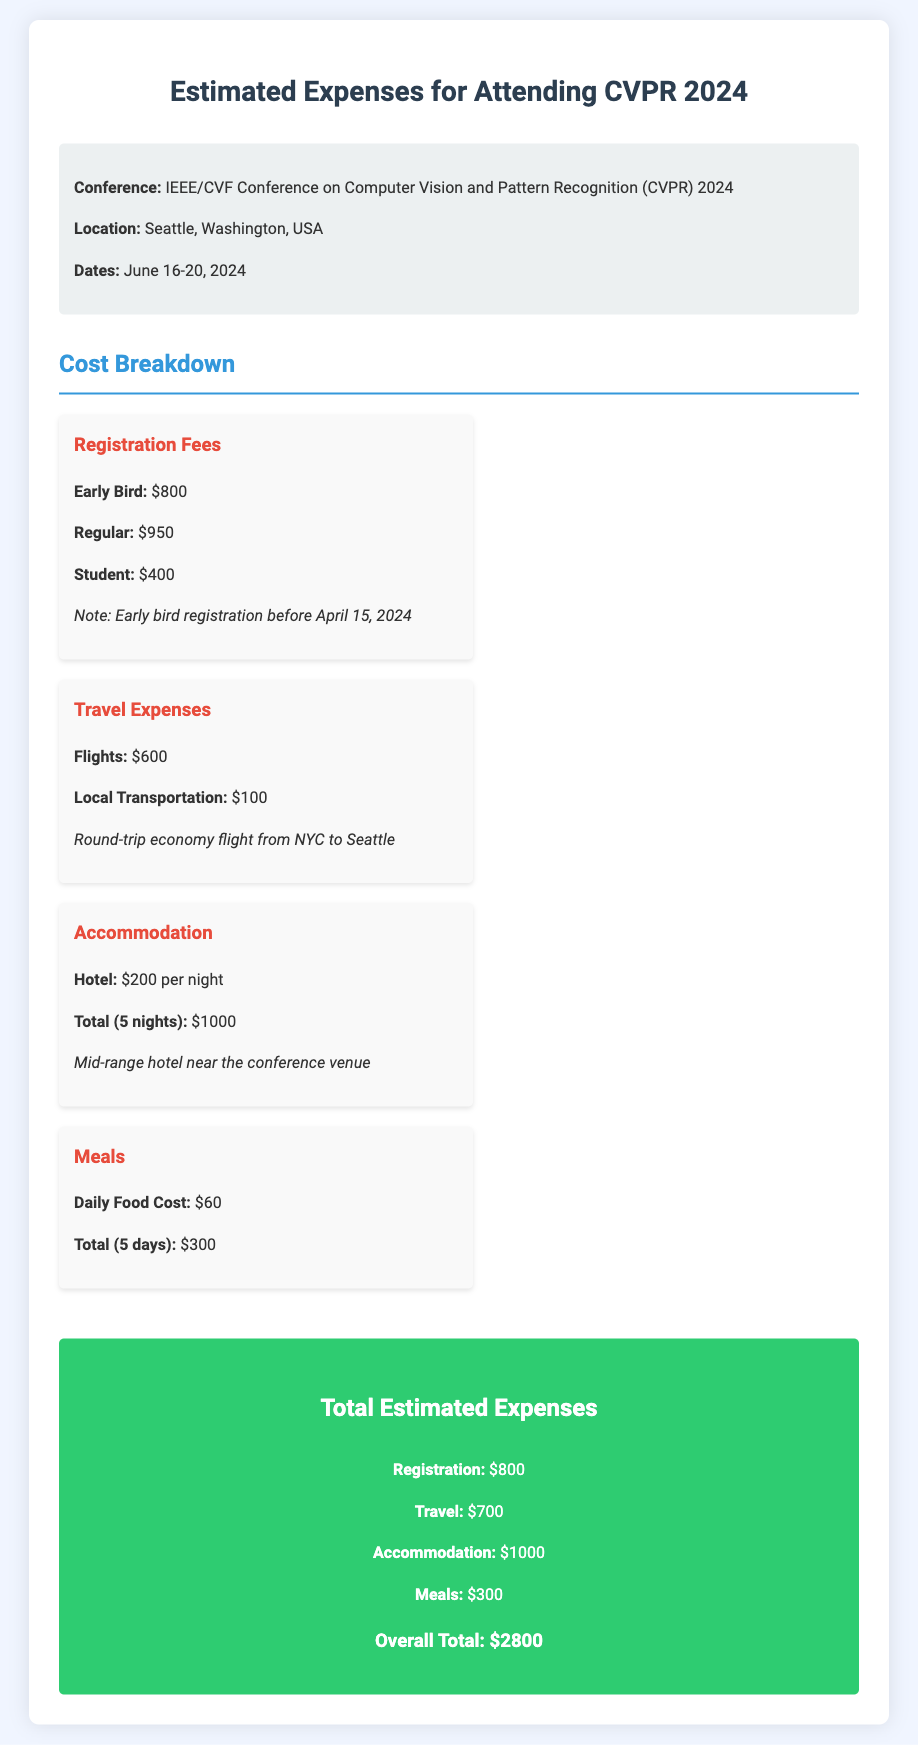What is the location of the conference? The location of the conference is specified in the document as Seattle, Washington, USA.
Answer: Seattle, Washington, USA What are the dates of CVPR 2024? The dates of the conference are given as June 16-20, 2024.
Answer: June 16-20, 2024 What is the early bird registration fee? The document states that the early bird registration fee is $800.
Answer: $800 How much is the hotel cost per night? The document mentions that the hotel costs $200 per night.
Answer: $200 What is the total estimated cost for meals? The total for meals is calculated for 5 days at $60 per day, totaling $300.
Answer: $300 How much is the total estimated expense for attending the conference? The overall total is the sum of registration, travel, accommodation, and meals, which is $2800.
Answer: $2800 If registered before April 15, 2024, what is the registration fee for students? The document specifies that the registration fee for students is $400.
Answer: $400 How many nights of accommodation are included in the budget? The budget includes 5 nights of accommodation as per the details given in the document.
Answer: 5 nights What is the total cost for travel expenses? The document states that the total travel expenses amount to $700.
Answer: $700 